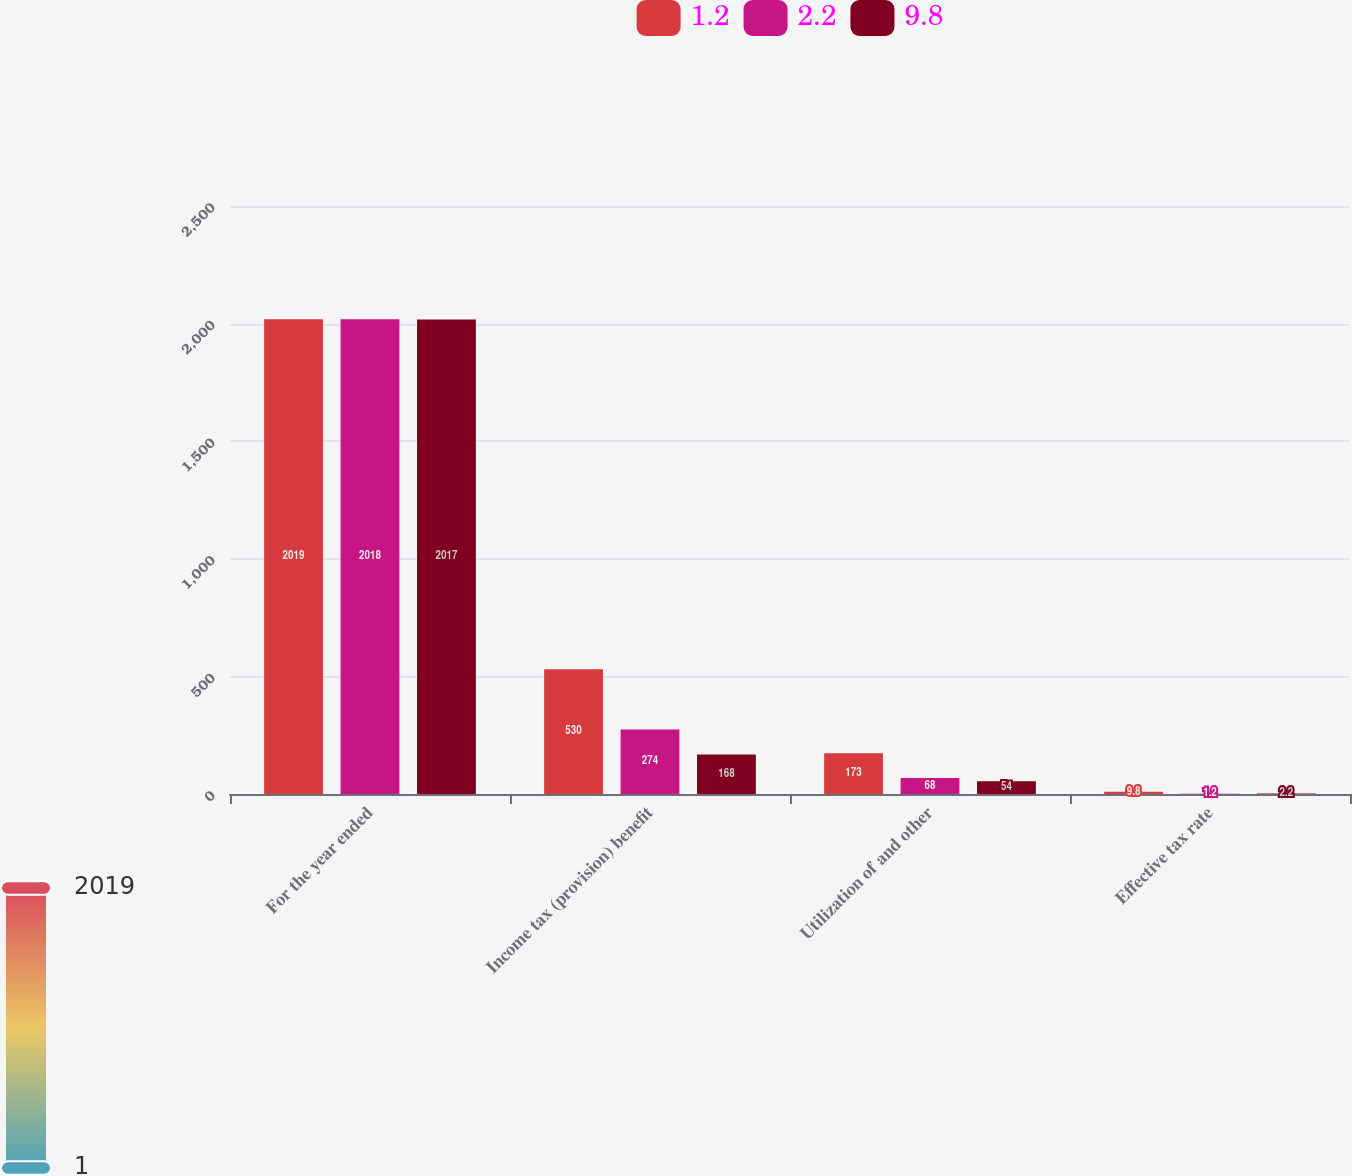<chart> <loc_0><loc_0><loc_500><loc_500><stacked_bar_chart><ecel><fcel>For the year ended<fcel>Income tax (provision) benefit<fcel>Utilization of and other<fcel>Effective tax rate<nl><fcel>1.2<fcel>2019<fcel>530<fcel>173<fcel>9.8<nl><fcel>2.2<fcel>2018<fcel>274<fcel>68<fcel>1.2<nl><fcel>9.8<fcel>2017<fcel>168<fcel>54<fcel>2.2<nl></chart> 